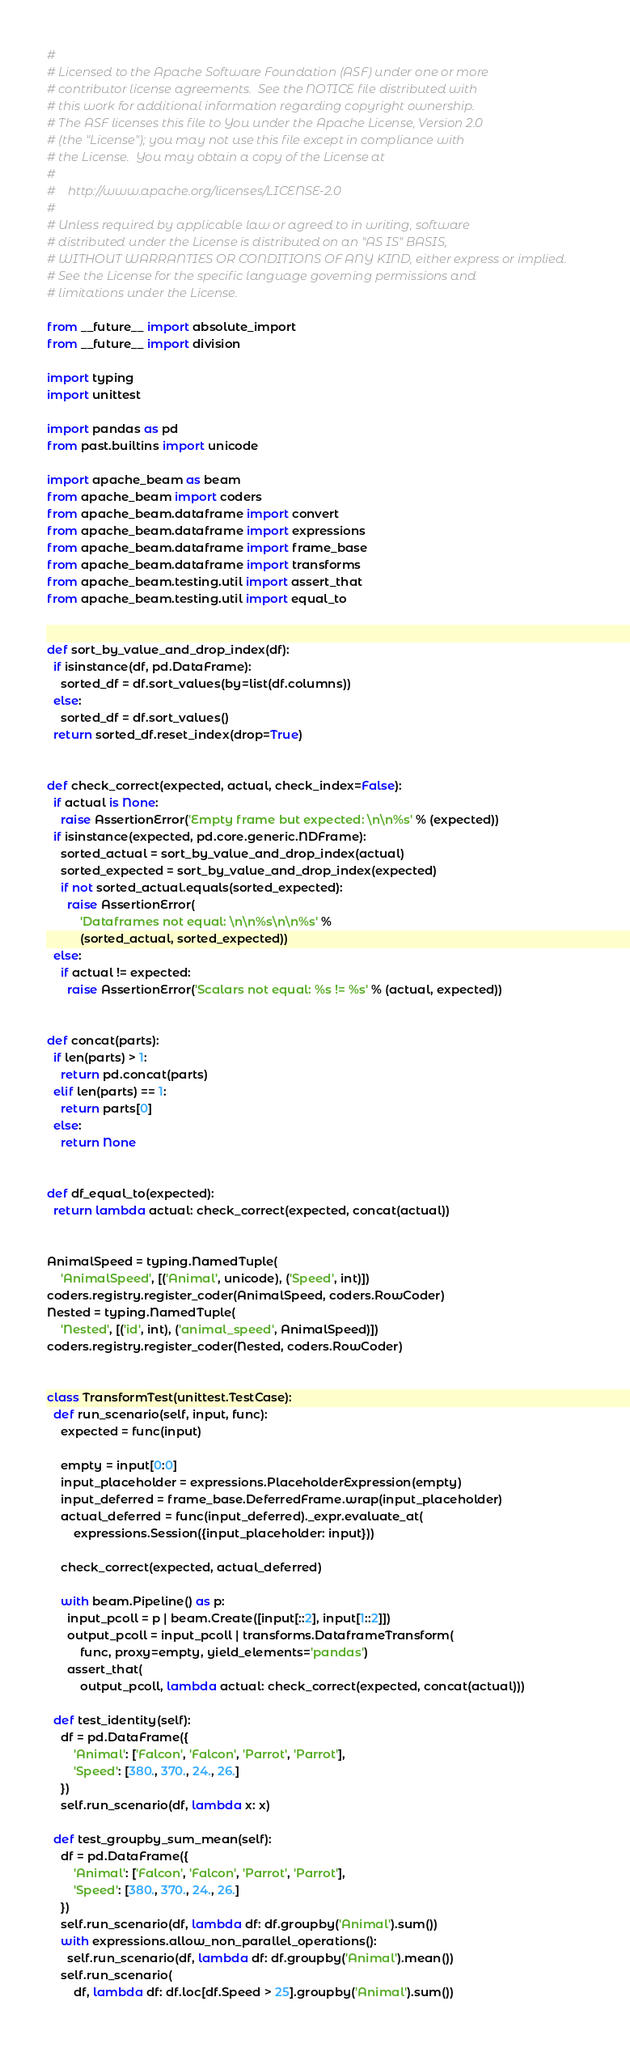Convert code to text. <code><loc_0><loc_0><loc_500><loc_500><_Python_>#
# Licensed to the Apache Software Foundation (ASF) under one or more
# contributor license agreements.  See the NOTICE file distributed with
# this work for additional information regarding copyright ownership.
# The ASF licenses this file to You under the Apache License, Version 2.0
# (the "License"); you may not use this file except in compliance with
# the License.  You may obtain a copy of the License at
#
#    http://www.apache.org/licenses/LICENSE-2.0
#
# Unless required by applicable law or agreed to in writing, software
# distributed under the License is distributed on an "AS IS" BASIS,
# WITHOUT WARRANTIES OR CONDITIONS OF ANY KIND, either express or implied.
# See the License for the specific language governing permissions and
# limitations under the License.

from __future__ import absolute_import
from __future__ import division

import typing
import unittest

import pandas as pd
from past.builtins import unicode

import apache_beam as beam
from apache_beam import coders
from apache_beam.dataframe import convert
from apache_beam.dataframe import expressions
from apache_beam.dataframe import frame_base
from apache_beam.dataframe import transforms
from apache_beam.testing.util import assert_that
from apache_beam.testing.util import equal_to


def sort_by_value_and_drop_index(df):
  if isinstance(df, pd.DataFrame):
    sorted_df = df.sort_values(by=list(df.columns))
  else:
    sorted_df = df.sort_values()
  return sorted_df.reset_index(drop=True)


def check_correct(expected, actual, check_index=False):
  if actual is None:
    raise AssertionError('Empty frame but expected: \n\n%s' % (expected))
  if isinstance(expected, pd.core.generic.NDFrame):
    sorted_actual = sort_by_value_and_drop_index(actual)
    sorted_expected = sort_by_value_and_drop_index(expected)
    if not sorted_actual.equals(sorted_expected):
      raise AssertionError(
          'Dataframes not equal: \n\n%s\n\n%s' %
          (sorted_actual, sorted_expected))
  else:
    if actual != expected:
      raise AssertionError('Scalars not equal: %s != %s' % (actual, expected))


def concat(parts):
  if len(parts) > 1:
    return pd.concat(parts)
  elif len(parts) == 1:
    return parts[0]
  else:
    return None


def df_equal_to(expected):
  return lambda actual: check_correct(expected, concat(actual))


AnimalSpeed = typing.NamedTuple(
    'AnimalSpeed', [('Animal', unicode), ('Speed', int)])
coders.registry.register_coder(AnimalSpeed, coders.RowCoder)
Nested = typing.NamedTuple(
    'Nested', [('id', int), ('animal_speed', AnimalSpeed)])
coders.registry.register_coder(Nested, coders.RowCoder)


class TransformTest(unittest.TestCase):
  def run_scenario(self, input, func):
    expected = func(input)

    empty = input[0:0]
    input_placeholder = expressions.PlaceholderExpression(empty)
    input_deferred = frame_base.DeferredFrame.wrap(input_placeholder)
    actual_deferred = func(input_deferred)._expr.evaluate_at(
        expressions.Session({input_placeholder: input}))

    check_correct(expected, actual_deferred)

    with beam.Pipeline() as p:
      input_pcoll = p | beam.Create([input[::2], input[1::2]])
      output_pcoll = input_pcoll | transforms.DataframeTransform(
          func, proxy=empty, yield_elements='pandas')
      assert_that(
          output_pcoll, lambda actual: check_correct(expected, concat(actual)))

  def test_identity(self):
    df = pd.DataFrame({
        'Animal': ['Falcon', 'Falcon', 'Parrot', 'Parrot'],
        'Speed': [380., 370., 24., 26.]
    })
    self.run_scenario(df, lambda x: x)

  def test_groupby_sum_mean(self):
    df = pd.DataFrame({
        'Animal': ['Falcon', 'Falcon', 'Parrot', 'Parrot'],
        'Speed': [380., 370., 24., 26.]
    })
    self.run_scenario(df, lambda df: df.groupby('Animal').sum())
    with expressions.allow_non_parallel_operations():
      self.run_scenario(df, lambda df: df.groupby('Animal').mean())
    self.run_scenario(
        df, lambda df: df.loc[df.Speed > 25].groupby('Animal').sum())
</code> 